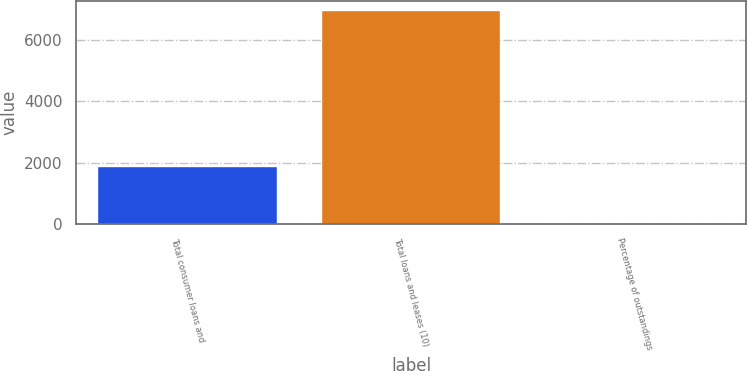Convert chart to OTSL. <chart><loc_0><loc_0><loc_500><loc_500><bar_chart><fcel>Total consumer loans and<fcel>Total loans and leases (10)<fcel>Percentage of outstandings<nl><fcel>1871<fcel>6938<fcel>0.77<nl></chart> 